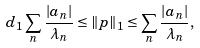Convert formula to latex. <formula><loc_0><loc_0><loc_500><loc_500>d _ { 1 } \sum _ { n } \frac { | a _ { n } | } { \lambda _ { n } } \leq \| p \| _ { 1 } \leq \sum _ { n } \frac { | a _ { n } | } { \lambda _ { n } } ,</formula> 